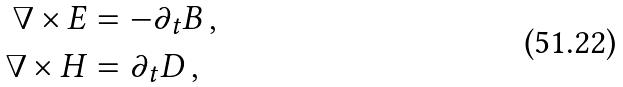<formula> <loc_0><loc_0><loc_500><loc_500>\nabla \times { E } & = - \partial _ { t } { B } \, , \\ \nabla \times { H } & = \partial _ { t } { D } \, ,</formula> 